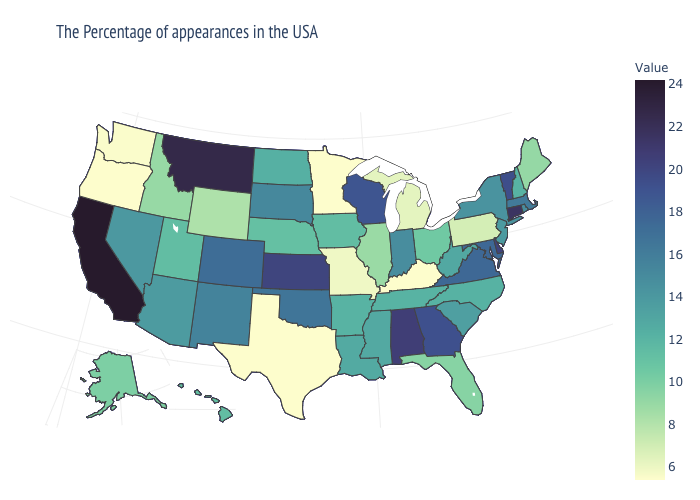Which states have the lowest value in the USA?
Short answer required. Kentucky, Minnesota, Texas, Oregon. Does Alabama have the highest value in the South?
Keep it brief. Yes. Which states hav the highest value in the MidWest?
Concise answer only. Kansas. Among the states that border Wyoming , does Idaho have the lowest value?
Quick response, please. Yes. Does Kentucky have the lowest value in the USA?
Keep it brief. Yes. 